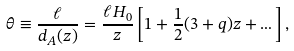Convert formula to latex. <formula><loc_0><loc_0><loc_500><loc_500>\theta \equiv \frac { \ell } { d _ { A } ( z ) } = \frac { \ell H _ { 0 } } { z } \left [ 1 + \frac { 1 } { 2 } ( 3 + q ) z + \dots \right ] ,</formula> 